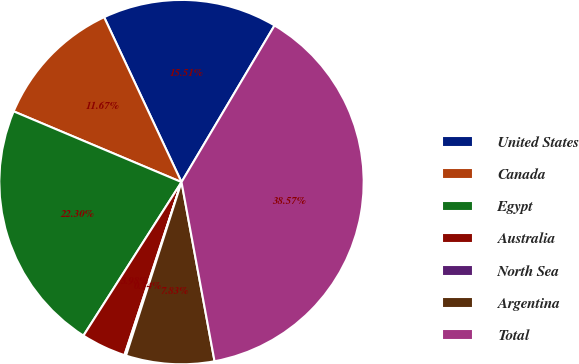Convert chart to OTSL. <chart><loc_0><loc_0><loc_500><loc_500><pie_chart><fcel>United States<fcel>Canada<fcel>Egypt<fcel>Australia<fcel>North Sea<fcel>Argentina<fcel>Total<nl><fcel>15.51%<fcel>11.67%<fcel>22.3%<fcel>3.98%<fcel>0.14%<fcel>7.83%<fcel>38.57%<nl></chart> 